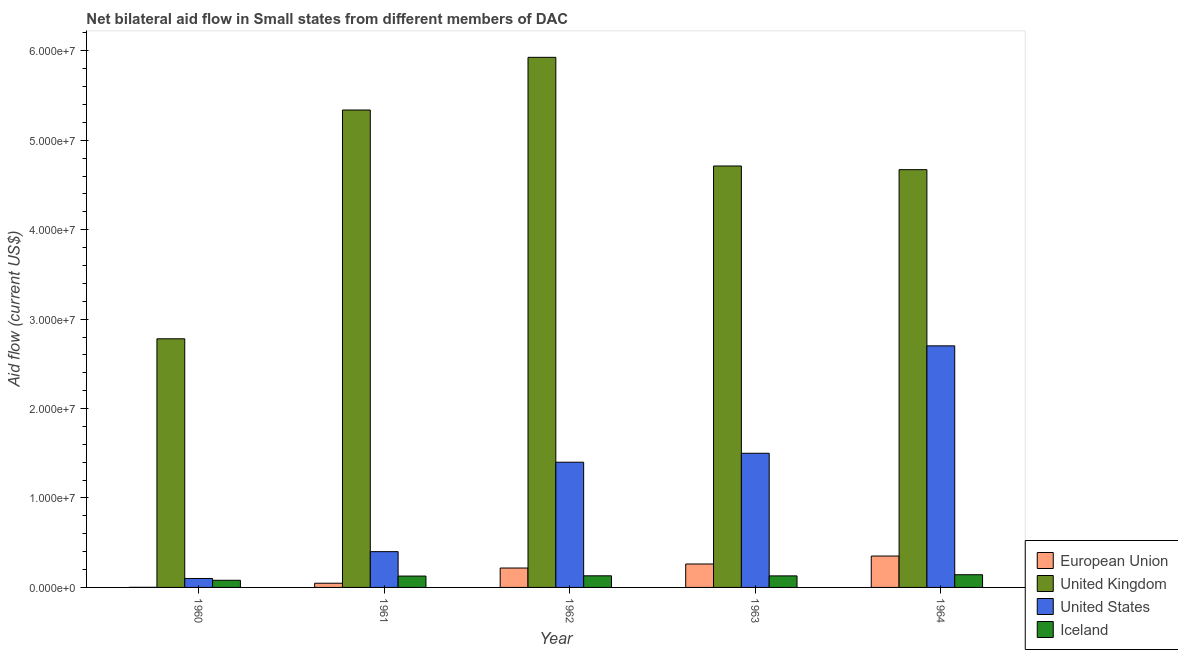How many groups of bars are there?
Your response must be concise. 5. Are the number of bars per tick equal to the number of legend labels?
Offer a very short reply. Yes. Are the number of bars on each tick of the X-axis equal?
Keep it short and to the point. Yes. In how many cases, is the number of bars for a given year not equal to the number of legend labels?
Your answer should be compact. 0. What is the amount of aid given by us in 1961?
Your answer should be compact. 4.00e+06. Across all years, what is the maximum amount of aid given by eu?
Your answer should be very brief. 3.51e+06. Across all years, what is the minimum amount of aid given by uk?
Provide a succinct answer. 2.78e+07. In which year was the amount of aid given by iceland minimum?
Offer a terse response. 1960. What is the total amount of aid given by eu in the graph?
Provide a short and direct response. 8.78e+06. What is the difference between the amount of aid given by iceland in 1960 and that in 1962?
Make the answer very short. -5.00e+05. What is the difference between the amount of aid given by iceland in 1960 and the amount of aid given by eu in 1961?
Offer a very short reply. -4.70e+05. What is the average amount of aid given by uk per year?
Give a very brief answer. 4.69e+07. What is the ratio of the amount of aid given by us in 1960 to that in 1963?
Offer a terse response. 0.07. Is the amount of aid given by iceland in 1960 less than that in 1963?
Offer a terse response. Yes. What is the difference between the highest and the second highest amount of aid given by eu?
Offer a very short reply. 8.90e+05. What is the difference between the highest and the lowest amount of aid given by us?
Ensure brevity in your answer.  2.60e+07. In how many years, is the amount of aid given by eu greater than the average amount of aid given by eu taken over all years?
Ensure brevity in your answer.  3. How many bars are there?
Make the answer very short. 20. Are all the bars in the graph horizontal?
Your answer should be compact. No. What is the difference between two consecutive major ticks on the Y-axis?
Offer a terse response. 1.00e+07. Does the graph contain grids?
Provide a succinct answer. No. How many legend labels are there?
Provide a succinct answer. 4. How are the legend labels stacked?
Your answer should be compact. Vertical. What is the title of the graph?
Offer a terse response. Net bilateral aid flow in Small states from different members of DAC. What is the label or title of the X-axis?
Keep it short and to the point. Year. What is the Aid flow (current US$) in European Union in 1960?
Offer a terse response. 10000. What is the Aid flow (current US$) in United Kingdom in 1960?
Your answer should be very brief. 2.78e+07. What is the Aid flow (current US$) of United States in 1960?
Your response must be concise. 1.00e+06. What is the Aid flow (current US$) in United Kingdom in 1961?
Give a very brief answer. 5.34e+07. What is the Aid flow (current US$) in Iceland in 1961?
Make the answer very short. 1.27e+06. What is the Aid flow (current US$) in European Union in 1962?
Provide a succinct answer. 2.17e+06. What is the Aid flow (current US$) of United Kingdom in 1962?
Offer a very short reply. 5.93e+07. What is the Aid flow (current US$) of United States in 1962?
Give a very brief answer. 1.40e+07. What is the Aid flow (current US$) of Iceland in 1962?
Ensure brevity in your answer.  1.30e+06. What is the Aid flow (current US$) of European Union in 1963?
Your answer should be very brief. 2.62e+06. What is the Aid flow (current US$) in United Kingdom in 1963?
Your response must be concise. 4.71e+07. What is the Aid flow (current US$) in United States in 1963?
Your response must be concise. 1.50e+07. What is the Aid flow (current US$) in Iceland in 1963?
Give a very brief answer. 1.29e+06. What is the Aid flow (current US$) in European Union in 1964?
Make the answer very short. 3.51e+06. What is the Aid flow (current US$) in United Kingdom in 1964?
Your answer should be compact. 4.67e+07. What is the Aid flow (current US$) of United States in 1964?
Your answer should be very brief. 2.70e+07. What is the Aid flow (current US$) in Iceland in 1964?
Your answer should be very brief. 1.42e+06. Across all years, what is the maximum Aid flow (current US$) in European Union?
Your answer should be compact. 3.51e+06. Across all years, what is the maximum Aid flow (current US$) in United Kingdom?
Keep it short and to the point. 5.93e+07. Across all years, what is the maximum Aid flow (current US$) of United States?
Provide a short and direct response. 2.70e+07. Across all years, what is the maximum Aid flow (current US$) of Iceland?
Give a very brief answer. 1.42e+06. Across all years, what is the minimum Aid flow (current US$) of United Kingdom?
Your answer should be compact. 2.78e+07. Across all years, what is the minimum Aid flow (current US$) of Iceland?
Offer a very short reply. 8.00e+05. What is the total Aid flow (current US$) of European Union in the graph?
Your answer should be very brief. 8.78e+06. What is the total Aid flow (current US$) of United Kingdom in the graph?
Provide a succinct answer. 2.34e+08. What is the total Aid flow (current US$) in United States in the graph?
Provide a succinct answer. 6.10e+07. What is the total Aid flow (current US$) in Iceland in the graph?
Offer a very short reply. 6.08e+06. What is the difference between the Aid flow (current US$) of European Union in 1960 and that in 1961?
Offer a very short reply. -4.60e+05. What is the difference between the Aid flow (current US$) of United Kingdom in 1960 and that in 1961?
Your response must be concise. -2.56e+07. What is the difference between the Aid flow (current US$) of Iceland in 1960 and that in 1961?
Offer a terse response. -4.70e+05. What is the difference between the Aid flow (current US$) of European Union in 1960 and that in 1962?
Make the answer very short. -2.16e+06. What is the difference between the Aid flow (current US$) in United Kingdom in 1960 and that in 1962?
Make the answer very short. -3.15e+07. What is the difference between the Aid flow (current US$) in United States in 1960 and that in 1962?
Make the answer very short. -1.30e+07. What is the difference between the Aid flow (current US$) in Iceland in 1960 and that in 1962?
Give a very brief answer. -5.00e+05. What is the difference between the Aid flow (current US$) of European Union in 1960 and that in 1963?
Your answer should be very brief. -2.61e+06. What is the difference between the Aid flow (current US$) of United Kingdom in 1960 and that in 1963?
Ensure brevity in your answer.  -1.93e+07. What is the difference between the Aid flow (current US$) in United States in 1960 and that in 1963?
Ensure brevity in your answer.  -1.40e+07. What is the difference between the Aid flow (current US$) in Iceland in 1960 and that in 1963?
Ensure brevity in your answer.  -4.90e+05. What is the difference between the Aid flow (current US$) in European Union in 1960 and that in 1964?
Ensure brevity in your answer.  -3.50e+06. What is the difference between the Aid flow (current US$) of United Kingdom in 1960 and that in 1964?
Provide a succinct answer. -1.89e+07. What is the difference between the Aid flow (current US$) in United States in 1960 and that in 1964?
Your answer should be compact. -2.60e+07. What is the difference between the Aid flow (current US$) of Iceland in 1960 and that in 1964?
Provide a short and direct response. -6.20e+05. What is the difference between the Aid flow (current US$) in European Union in 1961 and that in 1962?
Ensure brevity in your answer.  -1.70e+06. What is the difference between the Aid flow (current US$) in United Kingdom in 1961 and that in 1962?
Offer a very short reply. -5.89e+06. What is the difference between the Aid flow (current US$) in United States in 1961 and that in 1962?
Your response must be concise. -1.00e+07. What is the difference between the Aid flow (current US$) in Iceland in 1961 and that in 1962?
Your response must be concise. -3.00e+04. What is the difference between the Aid flow (current US$) in European Union in 1961 and that in 1963?
Your response must be concise. -2.15e+06. What is the difference between the Aid flow (current US$) of United Kingdom in 1961 and that in 1963?
Offer a very short reply. 6.26e+06. What is the difference between the Aid flow (current US$) of United States in 1961 and that in 1963?
Ensure brevity in your answer.  -1.10e+07. What is the difference between the Aid flow (current US$) in Iceland in 1961 and that in 1963?
Make the answer very short. -2.00e+04. What is the difference between the Aid flow (current US$) of European Union in 1961 and that in 1964?
Provide a succinct answer. -3.04e+06. What is the difference between the Aid flow (current US$) of United Kingdom in 1961 and that in 1964?
Make the answer very short. 6.67e+06. What is the difference between the Aid flow (current US$) in United States in 1961 and that in 1964?
Make the answer very short. -2.30e+07. What is the difference between the Aid flow (current US$) in European Union in 1962 and that in 1963?
Provide a succinct answer. -4.50e+05. What is the difference between the Aid flow (current US$) in United Kingdom in 1962 and that in 1963?
Make the answer very short. 1.22e+07. What is the difference between the Aid flow (current US$) of United States in 1962 and that in 1963?
Offer a terse response. -1.00e+06. What is the difference between the Aid flow (current US$) in Iceland in 1962 and that in 1963?
Ensure brevity in your answer.  10000. What is the difference between the Aid flow (current US$) of European Union in 1962 and that in 1964?
Give a very brief answer. -1.34e+06. What is the difference between the Aid flow (current US$) of United Kingdom in 1962 and that in 1964?
Offer a very short reply. 1.26e+07. What is the difference between the Aid flow (current US$) in United States in 1962 and that in 1964?
Provide a succinct answer. -1.30e+07. What is the difference between the Aid flow (current US$) in Iceland in 1962 and that in 1964?
Give a very brief answer. -1.20e+05. What is the difference between the Aid flow (current US$) in European Union in 1963 and that in 1964?
Your answer should be compact. -8.90e+05. What is the difference between the Aid flow (current US$) of United Kingdom in 1963 and that in 1964?
Your answer should be compact. 4.10e+05. What is the difference between the Aid flow (current US$) in United States in 1963 and that in 1964?
Give a very brief answer. -1.20e+07. What is the difference between the Aid flow (current US$) of Iceland in 1963 and that in 1964?
Provide a short and direct response. -1.30e+05. What is the difference between the Aid flow (current US$) of European Union in 1960 and the Aid flow (current US$) of United Kingdom in 1961?
Provide a short and direct response. -5.34e+07. What is the difference between the Aid flow (current US$) in European Union in 1960 and the Aid flow (current US$) in United States in 1961?
Your response must be concise. -3.99e+06. What is the difference between the Aid flow (current US$) of European Union in 1960 and the Aid flow (current US$) of Iceland in 1961?
Ensure brevity in your answer.  -1.26e+06. What is the difference between the Aid flow (current US$) in United Kingdom in 1960 and the Aid flow (current US$) in United States in 1961?
Offer a terse response. 2.38e+07. What is the difference between the Aid flow (current US$) in United Kingdom in 1960 and the Aid flow (current US$) in Iceland in 1961?
Ensure brevity in your answer.  2.65e+07. What is the difference between the Aid flow (current US$) of European Union in 1960 and the Aid flow (current US$) of United Kingdom in 1962?
Provide a short and direct response. -5.93e+07. What is the difference between the Aid flow (current US$) in European Union in 1960 and the Aid flow (current US$) in United States in 1962?
Ensure brevity in your answer.  -1.40e+07. What is the difference between the Aid flow (current US$) of European Union in 1960 and the Aid flow (current US$) of Iceland in 1962?
Your answer should be very brief. -1.29e+06. What is the difference between the Aid flow (current US$) in United Kingdom in 1960 and the Aid flow (current US$) in United States in 1962?
Give a very brief answer. 1.38e+07. What is the difference between the Aid flow (current US$) of United Kingdom in 1960 and the Aid flow (current US$) of Iceland in 1962?
Your answer should be compact. 2.65e+07. What is the difference between the Aid flow (current US$) of European Union in 1960 and the Aid flow (current US$) of United Kingdom in 1963?
Your answer should be compact. -4.71e+07. What is the difference between the Aid flow (current US$) in European Union in 1960 and the Aid flow (current US$) in United States in 1963?
Your answer should be very brief. -1.50e+07. What is the difference between the Aid flow (current US$) in European Union in 1960 and the Aid flow (current US$) in Iceland in 1963?
Keep it short and to the point. -1.28e+06. What is the difference between the Aid flow (current US$) in United Kingdom in 1960 and the Aid flow (current US$) in United States in 1963?
Your response must be concise. 1.28e+07. What is the difference between the Aid flow (current US$) of United Kingdom in 1960 and the Aid flow (current US$) of Iceland in 1963?
Keep it short and to the point. 2.65e+07. What is the difference between the Aid flow (current US$) of United States in 1960 and the Aid flow (current US$) of Iceland in 1963?
Offer a terse response. -2.90e+05. What is the difference between the Aid flow (current US$) in European Union in 1960 and the Aid flow (current US$) in United Kingdom in 1964?
Your answer should be very brief. -4.67e+07. What is the difference between the Aid flow (current US$) of European Union in 1960 and the Aid flow (current US$) of United States in 1964?
Provide a succinct answer. -2.70e+07. What is the difference between the Aid flow (current US$) in European Union in 1960 and the Aid flow (current US$) in Iceland in 1964?
Your response must be concise. -1.41e+06. What is the difference between the Aid flow (current US$) of United Kingdom in 1960 and the Aid flow (current US$) of United States in 1964?
Offer a terse response. 7.90e+05. What is the difference between the Aid flow (current US$) of United Kingdom in 1960 and the Aid flow (current US$) of Iceland in 1964?
Provide a succinct answer. 2.64e+07. What is the difference between the Aid flow (current US$) in United States in 1960 and the Aid flow (current US$) in Iceland in 1964?
Give a very brief answer. -4.20e+05. What is the difference between the Aid flow (current US$) of European Union in 1961 and the Aid flow (current US$) of United Kingdom in 1962?
Your answer should be very brief. -5.88e+07. What is the difference between the Aid flow (current US$) of European Union in 1961 and the Aid flow (current US$) of United States in 1962?
Your answer should be compact. -1.35e+07. What is the difference between the Aid flow (current US$) in European Union in 1961 and the Aid flow (current US$) in Iceland in 1962?
Ensure brevity in your answer.  -8.30e+05. What is the difference between the Aid flow (current US$) in United Kingdom in 1961 and the Aid flow (current US$) in United States in 1962?
Offer a terse response. 3.94e+07. What is the difference between the Aid flow (current US$) in United Kingdom in 1961 and the Aid flow (current US$) in Iceland in 1962?
Provide a short and direct response. 5.21e+07. What is the difference between the Aid flow (current US$) in United States in 1961 and the Aid flow (current US$) in Iceland in 1962?
Offer a terse response. 2.70e+06. What is the difference between the Aid flow (current US$) in European Union in 1961 and the Aid flow (current US$) in United Kingdom in 1963?
Your answer should be very brief. -4.66e+07. What is the difference between the Aid flow (current US$) of European Union in 1961 and the Aid flow (current US$) of United States in 1963?
Your response must be concise. -1.45e+07. What is the difference between the Aid flow (current US$) in European Union in 1961 and the Aid flow (current US$) in Iceland in 1963?
Offer a terse response. -8.20e+05. What is the difference between the Aid flow (current US$) in United Kingdom in 1961 and the Aid flow (current US$) in United States in 1963?
Offer a terse response. 3.84e+07. What is the difference between the Aid flow (current US$) of United Kingdom in 1961 and the Aid flow (current US$) of Iceland in 1963?
Provide a short and direct response. 5.21e+07. What is the difference between the Aid flow (current US$) in United States in 1961 and the Aid flow (current US$) in Iceland in 1963?
Your response must be concise. 2.71e+06. What is the difference between the Aid flow (current US$) in European Union in 1961 and the Aid flow (current US$) in United Kingdom in 1964?
Offer a terse response. -4.62e+07. What is the difference between the Aid flow (current US$) in European Union in 1961 and the Aid flow (current US$) in United States in 1964?
Ensure brevity in your answer.  -2.65e+07. What is the difference between the Aid flow (current US$) in European Union in 1961 and the Aid flow (current US$) in Iceland in 1964?
Offer a very short reply. -9.50e+05. What is the difference between the Aid flow (current US$) in United Kingdom in 1961 and the Aid flow (current US$) in United States in 1964?
Make the answer very short. 2.64e+07. What is the difference between the Aid flow (current US$) in United Kingdom in 1961 and the Aid flow (current US$) in Iceland in 1964?
Provide a short and direct response. 5.20e+07. What is the difference between the Aid flow (current US$) of United States in 1961 and the Aid flow (current US$) of Iceland in 1964?
Give a very brief answer. 2.58e+06. What is the difference between the Aid flow (current US$) in European Union in 1962 and the Aid flow (current US$) in United Kingdom in 1963?
Ensure brevity in your answer.  -4.50e+07. What is the difference between the Aid flow (current US$) in European Union in 1962 and the Aid flow (current US$) in United States in 1963?
Your answer should be very brief. -1.28e+07. What is the difference between the Aid flow (current US$) in European Union in 1962 and the Aid flow (current US$) in Iceland in 1963?
Ensure brevity in your answer.  8.80e+05. What is the difference between the Aid flow (current US$) of United Kingdom in 1962 and the Aid flow (current US$) of United States in 1963?
Ensure brevity in your answer.  4.43e+07. What is the difference between the Aid flow (current US$) in United Kingdom in 1962 and the Aid flow (current US$) in Iceland in 1963?
Your answer should be compact. 5.80e+07. What is the difference between the Aid flow (current US$) of United States in 1962 and the Aid flow (current US$) of Iceland in 1963?
Your response must be concise. 1.27e+07. What is the difference between the Aid flow (current US$) of European Union in 1962 and the Aid flow (current US$) of United Kingdom in 1964?
Make the answer very short. -4.45e+07. What is the difference between the Aid flow (current US$) in European Union in 1962 and the Aid flow (current US$) in United States in 1964?
Make the answer very short. -2.48e+07. What is the difference between the Aid flow (current US$) of European Union in 1962 and the Aid flow (current US$) of Iceland in 1964?
Provide a succinct answer. 7.50e+05. What is the difference between the Aid flow (current US$) of United Kingdom in 1962 and the Aid flow (current US$) of United States in 1964?
Your answer should be compact. 3.23e+07. What is the difference between the Aid flow (current US$) in United Kingdom in 1962 and the Aid flow (current US$) in Iceland in 1964?
Give a very brief answer. 5.78e+07. What is the difference between the Aid flow (current US$) in United States in 1962 and the Aid flow (current US$) in Iceland in 1964?
Keep it short and to the point. 1.26e+07. What is the difference between the Aid flow (current US$) of European Union in 1963 and the Aid flow (current US$) of United Kingdom in 1964?
Provide a succinct answer. -4.41e+07. What is the difference between the Aid flow (current US$) of European Union in 1963 and the Aid flow (current US$) of United States in 1964?
Your answer should be compact. -2.44e+07. What is the difference between the Aid flow (current US$) in European Union in 1963 and the Aid flow (current US$) in Iceland in 1964?
Your answer should be compact. 1.20e+06. What is the difference between the Aid flow (current US$) of United Kingdom in 1963 and the Aid flow (current US$) of United States in 1964?
Make the answer very short. 2.01e+07. What is the difference between the Aid flow (current US$) in United Kingdom in 1963 and the Aid flow (current US$) in Iceland in 1964?
Your answer should be very brief. 4.57e+07. What is the difference between the Aid flow (current US$) in United States in 1963 and the Aid flow (current US$) in Iceland in 1964?
Give a very brief answer. 1.36e+07. What is the average Aid flow (current US$) of European Union per year?
Make the answer very short. 1.76e+06. What is the average Aid flow (current US$) of United Kingdom per year?
Your answer should be compact. 4.69e+07. What is the average Aid flow (current US$) of United States per year?
Offer a very short reply. 1.22e+07. What is the average Aid flow (current US$) in Iceland per year?
Your answer should be compact. 1.22e+06. In the year 1960, what is the difference between the Aid flow (current US$) in European Union and Aid flow (current US$) in United Kingdom?
Make the answer very short. -2.78e+07. In the year 1960, what is the difference between the Aid flow (current US$) in European Union and Aid flow (current US$) in United States?
Give a very brief answer. -9.90e+05. In the year 1960, what is the difference between the Aid flow (current US$) of European Union and Aid flow (current US$) of Iceland?
Provide a succinct answer. -7.90e+05. In the year 1960, what is the difference between the Aid flow (current US$) of United Kingdom and Aid flow (current US$) of United States?
Ensure brevity in your answer.  2.68e+07. In the year 1960, what is the difference between the Aid flow (current US$) in United Kingdom and Aid flow (current US$) in Iceland?
Give a very brief answer. 2.70e+07. In the year 1961, what is the difference between the Aid flow (current US$) of European Union and Aid flow (current US$) of United Kingdom?
Your response must be concise. -5.29e+07. In the year 1961, what is the difference between the Aid flow (current US$) in European Union and Aid flow (current US$) in United States?
Provide a short and direct response. -3.53e+06. In the year 1961, what is the difference between the Aid flow (current US$) in European Union and Aid flow (current US$) in Iceland?
Your answer should be very brief. -8.00e+05. In the year 1961, what is the difference between the Aid flow (current US$) in United Kingdom and Aid flow (current US$) in United States?
Your answer should be compact. 4.94e+07. In the year 1961, what is the difference between the Aid flow (current US$) in United Kingdom and Aid flow (current US$) in Iceland?
Offer a very short reply. 5.21e+07. In the year 1961, what is the difference between the Aid flow (current US$) in United States and Aid flow (current US$) in Iceland?
Your response must be concise. 2.73e+06. In the year 1962, what is the difference between the Aid flow (current US$) in European Union and Aid flow (current US$) in United Kingdom?
Offer a very short reply. -5.71e+07. In the year 1962, what is the difference between the Aid flow (current US$) in European Union and Aid flow (current US$) in United States?
Your answer should be compact. -1.18e+07. In the year 1962, what is the difference between the Aid flow (current US$) in European Union and Aid flow (current US$) in Iceland?
Your answer should be very brief. 8.70e+05. In the year 1962, what is the difference between the Aid flow (current US$) of United Kingdom and Aid flow (current US$) of United States?
Your response must be concise. 4.53e+07. In the year 1962, what is the difference between the Aid flow (current US$) of United Kingdom and Aid flow (current US$) of Iceland?
Keep it short and to the point. 5.80e+07. In the year 1962, what is the difference between the Aid flow (current US$) in United States and Aid flow (current US$) in Iceland?
Give a very brief answer. 1.27e+07. In the year 1963, what is the difference between the Aid flow (current US$) in European Union and Aid flow (current US$) in United Kingdom?
Give a very brief answer. -4.45e+07. In the year 1963, what is the difference between the Aid flow (current US$) of European Union and Aid flow (current US$) of United States?
Offer a terse response. -1.24e+07. In the year 1963, what is the difference between the Aid flow (current US$) in European Union and Aid flow (current US$) in Iceland?
Make the answer very short. 1.33e+06. In the year 1963, what is the difference between the Aid flow (current US$) in United Kingdom and Aid flow (current US$) in United States?
Offer a terse response. 3.21e+07. In the year 1963, what is the difference between the Aid flow (current US$) of United Kingdom and Aid flow (current US$) of Iceland?
Your answer should be compact. 4.58e+07. In the year 1963, what is the difference between the Aid flow (current US$) in United States and Aid flow (current US$) in Iceland?
Provide a succinct answer. 1.37e+07. In the year 1964, what is the difference between the Aid flow (current US$) of European Union and Aid flow (current US$) of United Kingdom?
Make the answer very short. -4.32e+07. In the year 1964, what is the difference between the Aid flow (current US$) in European Union and Aid flow (current US$) in United States?
Provide a succinct answer. -2.35e+07. In the year 1964, what is the difference between the Aid flow (current US$) of European Union and Aid flow (current US$) of Iceland?
Your answer should be compact. 2.09e+06. In the year 1964, what is the difference between the Aid flow (current US$) of United Kingdom and Aid flow (current US$) of United States?
Keep it short and to the point. 1.97e+07. In the year 1964, what is the difference between the Aid flow (current US$) of United Kingdom and Aid flow (current US$) of Iceland?
Make the answer very short. 4.53e+07. In the year 1964, what is the difference between the Aid flow (current US$) of United States and Aid flow (current US$) of Iceland?
Your response must be concise. 2.56e+07. What is the ratio of the Aid flow (current US$) of European Union in 1960 to that in 1961?
Your answer should be compact. 0.02. What is the ratio of the Aid flow (current US$) of United Kingdom in 1960 to that in 1961?
Ensure brevity in your answer.  0.52. What is the ratio of the Aid flow (current US$) in Iceland in 1960 to that in 1961?
Your answer should be compact. 0.63. What is the ratio of the Aid flow (current US$) of European Union in 1960 to that in 1962?
Your answer should be very brief. 0. What is the ratio of the Aid flow (current US$) in United Kingdom in 1960 to that in 1962?
Give a very brief answer. 0.47. What is the ratio of the Aid flow (current US$) in United States in 1960 to that in 1962?
Provide a succinct answer. 0.07. What is the ratio of the Aid flow (current US$) of Iceland in 1960 to that in 1962?
Ensure brevity in your answer.  0.62. What is the ratio of the Aid flow (current US$) in European Union in 1960 to that in 1963?
Keep it short and to the point. 0. What is the ratio of the Aid flow (current US$) in United Kingdom in 1960 to that in 1963?
Make the answer very short. 0.59. What is the ratio of the Aid flow (current US$) of United States in 1960 to that in 1963?
Offer a terse response. 0.07. What is the ratio of the Aid flow (current US$) in Iceland in 1960 to that in 1963?
Provide a succinct answer. 0.62. What is the ratio of the Aid flow (current US$) of European Union in 1960 to that in 1964?
Ensure brevity in your answer.  0. What is the ratio of the Aid flow (current US$) of United Kingdom in 1960 to that in 1964?
Give a very brief answer. 0.6. What is the ratio of the Aid flow (current US$) in United States in 1960 to that in 1964?
Make the answer very short. 0.04. What is the ratio of the Aid flow (current US$) of Iceland in 1960 to that in 1964?
Your answer should be compact. 0.56. What is the ratio of the Aid flow (current US$) of European Union in 1961 to that in 1962?
Give a very brief answer. 0.22. What is the ratio of the Aid flow (current US$) in United Kingdom in 1961 to that in 1962?
Your response must be concise. 0.9. What is the ratio of the Aid flow (current US$) in United States in 1961 to that in 1962?
Ensure brevity in your answer.  0.29. What is the ratio of the Aid flow (current US$) in Iceland in 1961 to that in 1962?
Your answer should be very brief. 0.98. What is the ratio of the Aid flow (current US$) in European Union in 1961 to that in 1963?
Your answer should be very brief. 0.18. What is the ratio of the Aid flow (current US$) in United Kingdom in 1961 to that in 1963?
Give a very brief answer. 1.13. What is the ratio of the Aid flow (current US$) of United States in 1961 to that in 1963?
Offer a terse response. 0.27. What is the ratio of the Aid flow (current US$) of Iceland in 1961 to that in 1963?
Give a very brief answer. 0.98. What is the ratio of the Aid flow (current US$) in European Union in 1961 to that in 1964?
Keep it short and to the point. 0.13. What is the ratio of the Aid flow (current US$) of United Kingdom in 1961 to that in 1964?
Ensure brevity in your answer.  1.14. What is the ratio of the Aid flow (current US$) of United States in 1961 to that in 1964?
Provide a succinct answer. 0.15. What is the ratio of the Aid flow (current US$) in Iceland in 1961 to that in 1964?
Provide a succinct answer. 0.89. What is the ratio of the Aid flow (current US$) in European Union in 1962 to that in 1963?
Ensure brevity in your answer.  0.83. What is the ratio of the Aid flow (current US$) in United Kingdom in 1962 to that in 1963?
Provide a succinct answer. 1.26. What is the ratio of the Aid flow (current US$) in United States in 1962 to that in 1963?
Your answer should be compact. 0.93. What is the ratio of the Aid flow (current US$) in Iceland in 1962 to that in 1963?
Give a very brief answer. 1.01. What is the ratio of the Aid flow (current US$) in European Union in 1962 to that in 1964?
Give a very brief answer. 0.62. What is the ratio of the Aid flow (current US$) of United Kingdom in 1962 to that in 1964?
Your answer should be compact. 1.27. What is the ratio of the Aid flow (current US$) in United States in 1962 to that in 1964?
Your answer should be very brief. 0.52. What is the ratio of the Aid flow (current US$) of Iceland in 1962 to that in 1964?
Give a very brief answer. 0.92. What is the ratio of the Aid flow (current US$) of European Union in 1963 to that in 1964?
Your response must be concise. 0.75. What is the ratio of the Aid flow (current US$) of United Kingdom in 1963 to that in 1964?
Give a very brief answer. 1.01. What is the ratio of the Aid flow (current US$) of United States in 1963 to that in 1964?
Keep it short and to the point. 0.56. What is the ratio of the Aid flow (current US$) of Iceland in 1963 to that in 1964?
Offer a terse response. 0.91. What is the difference between the highest and the second highest Aid flow (current US$) in European Union?
Keep it short and to the point. 8.90e+05. What is the difference between the highest and the second highest Aid flow (current US$) in United Kingdom?
Offer a terse response. 5.89e+06. What is the difference between the highest and the second highest Aid flow (current US$) in United States?
Your answer should be compact. 1.20e+07. What is the difference between the highest and the lowest Aid flow (current US$) of European Union?
Give a very brief answer. 3.50e+06. What is the difference between the highest and the lowest Aid flow (current US$) of United Kingdom?
Your response must be concise. 3.15e+07. What is the difference between the highest and the lowest Aid flow (current US$) of United States?
Provide a short and direct response. 2.60e+07. What is the difference between the highest and the lowest Aid flow (current US$) of Iceland?
Your response must be concise. 6.20e+05. 